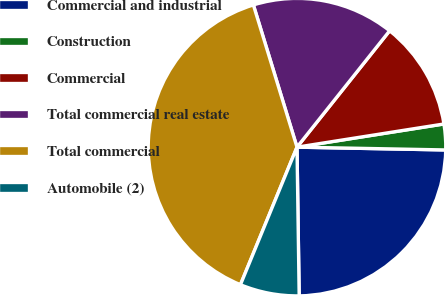Convert chart to OTSL. <chart><loc_0><loc_0><loc_500><loc_500><pie_chart><fcel>Commercial and industrial<fcel>Construction<fcel>Commercial<fcel>Total commercial real estate<fcel>Total commercial<fcel>Automobile (2)<nl><fcel>24.47%<fcel>2.79%<fcel>11.81%<fcel>15.44%<fcel>39.06%<fcel>6.44%<nl></chart> 